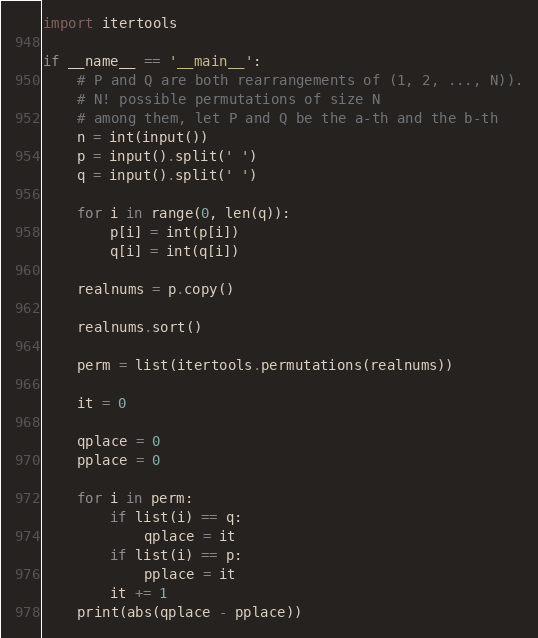Convert code to text. <code><loc_0><loc_0><loc_500><loc_500><_Python_>import itertools

if __name__ == '__main__':
    # P and Q are both rearrangements of (1, 2, ..., N)).
    # N! possible permutations of size N
    # among them, let P and Q be the a-th and the b-th
    n = int(input())
    p = input().split(' ')
    q = input().split(' ')

    for i in range(0, len(q)):
        p[i] = int(p[i])
        q[i] = int(q[i])

    realnums = p.copy()

    realnums.sort()

    perm = list(itertools.permutations(realnums))

    it = 0

    qplace = 0
    pplace = 0

    for i in perm:
        if list(i) == q:
            qplace = it
        if list(i) == p:
            pplace = it
        it += 1
    print(abs(qplace - pplace))</code> 